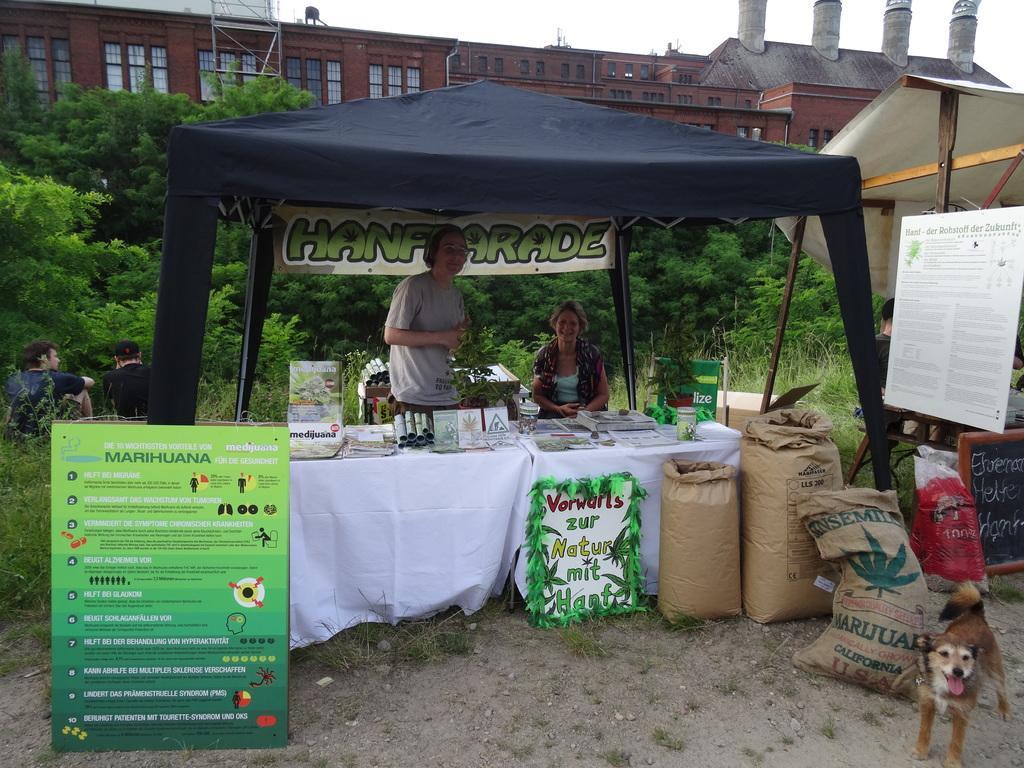Can you describe this image briefly? In this picture we can see the outside shop with an man and woman in the front and looking to the camera. Behind there is a brown color jute bags and poster poster banner. Behind there are some trees and brown building with glass window and four chimneys on the top. 